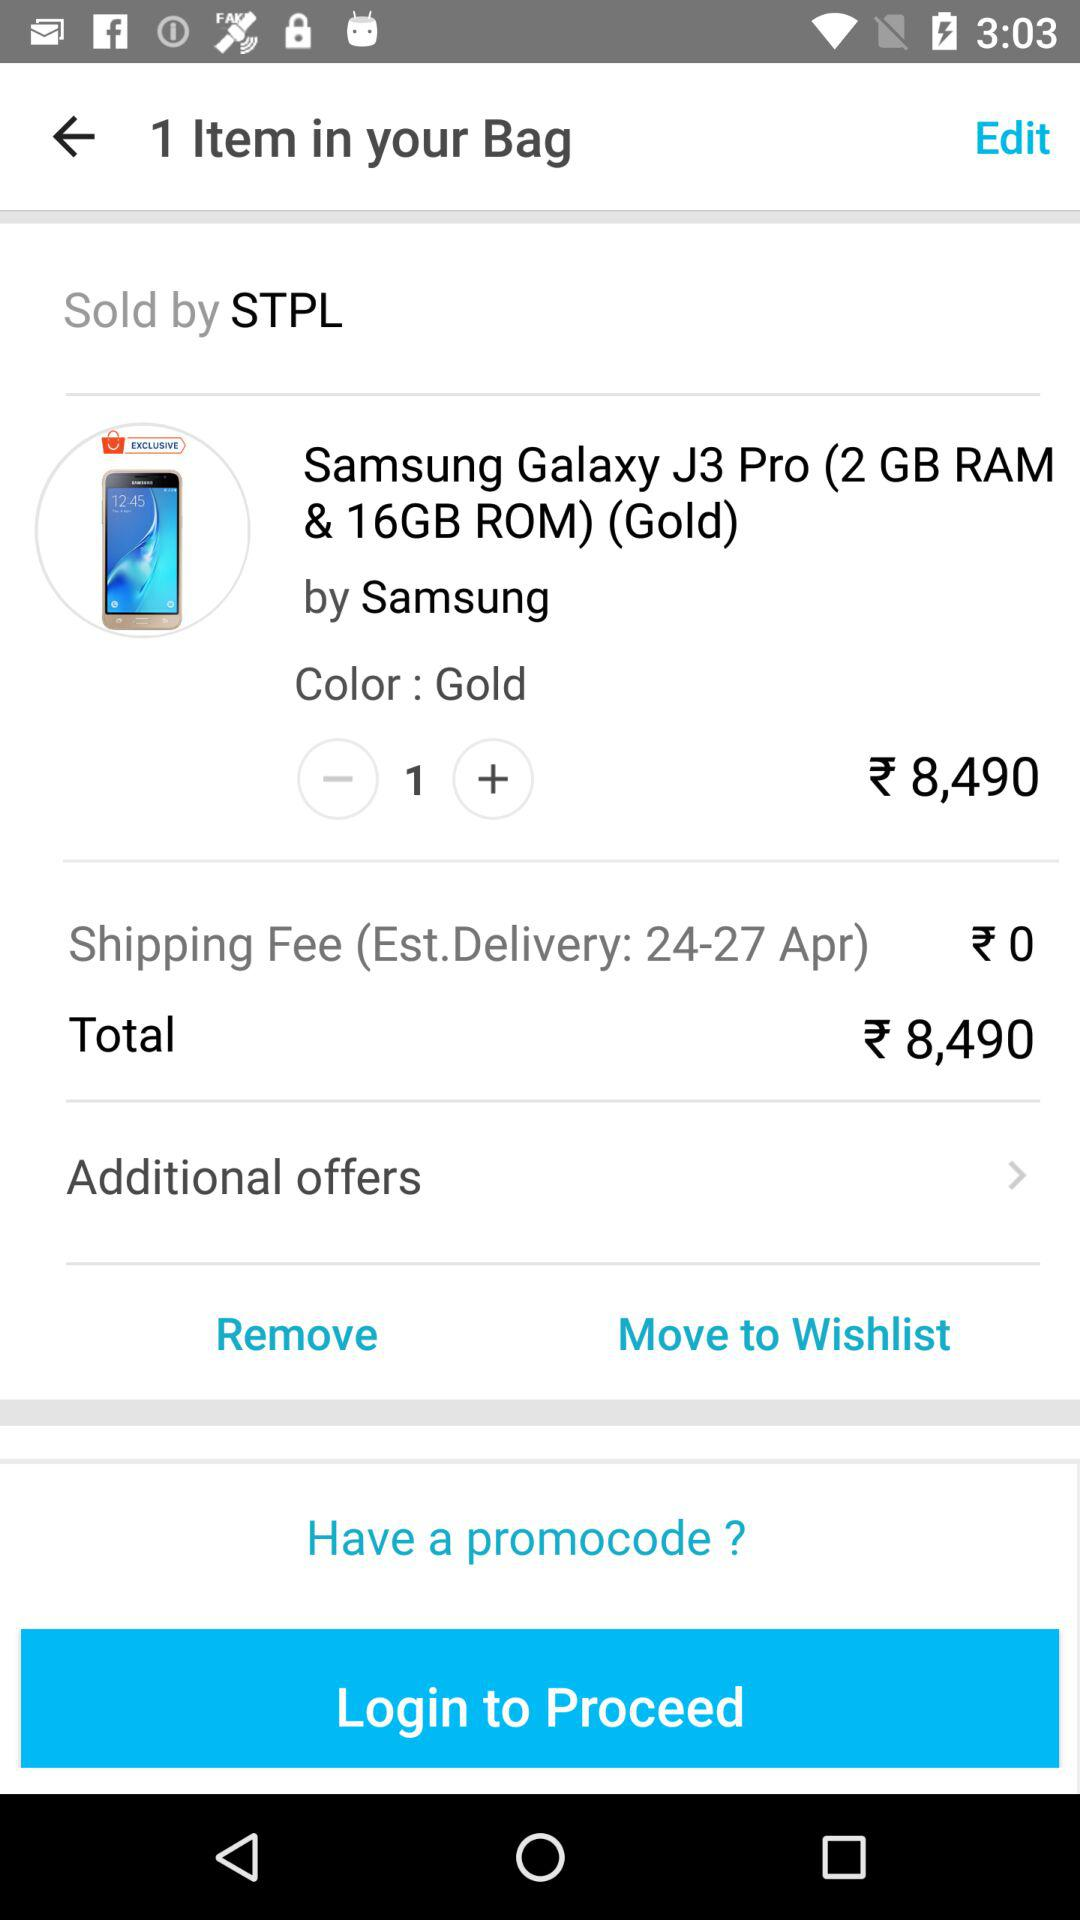What is the total price of the item?
Answer the question using a single word or phrase. ₹8,490 